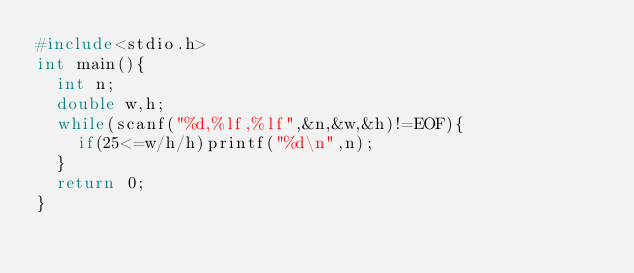<code> <loc_0><loc_0><loc_500><loc_500><_C_>#include<stdio.h>
int main(){
  int n;
  double w,h;
  while(scanf("%d,%lf,%lf",&n,&w,&h)!=EOF){
    if(25<=w/h/h)printf("%d\n",n);
  }
  return 0;
}</code> 